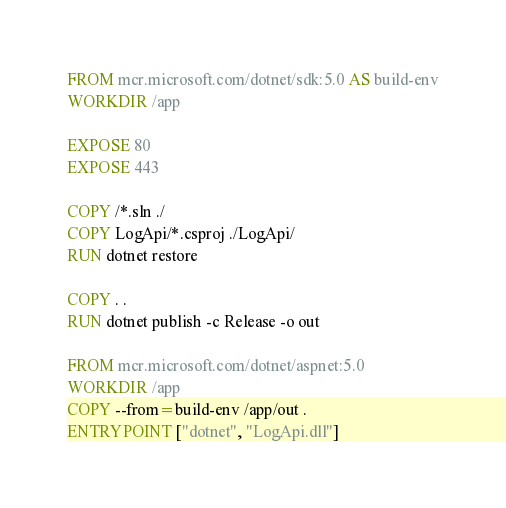Convert code to text. <code><loc_0><loc_0><loc_500><loc_500><_Dockerfile_>FROM mcr.microsoft.com/dotnet/sdk:5.0 AS build-env
WORKDIR /app

EXPOSE 80 
EXPOSE 443

COPY /*.sln ./
COPY LogApi/*.csproj ./LogApi/
RUN dotnet restore

COPY . .
RUN dotnet publish -c Release -o out

FROM mcr.microsoft.com/dotnet/aspnet:5.0
WORKDIR /app
COPY --from=build-env /app/out .
ENTRYPOINT ["dotnet", "LogApi.dll"]</code> 